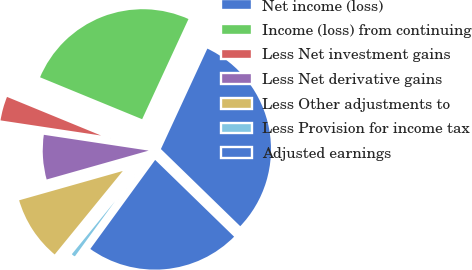Convert chart. <chart><loc_0><loc_0><loc_500><loc_500><pie_chart><fcel>Net income (loss)<fcel>Income (loss) from continuing<fcel>Less Net investment gains<fcel>Less Net derivative gains<fcel>Less Other adjustments to<fcel>Less Provision for income tax<fcel>Adjusted earnings<nl><fcel>30.38%<fcel>25.69%<fcel>3.82%<fcel>6.77%<fcel>9.72%<fcel>0.87%<fcel>22.74%<nl></chart> 